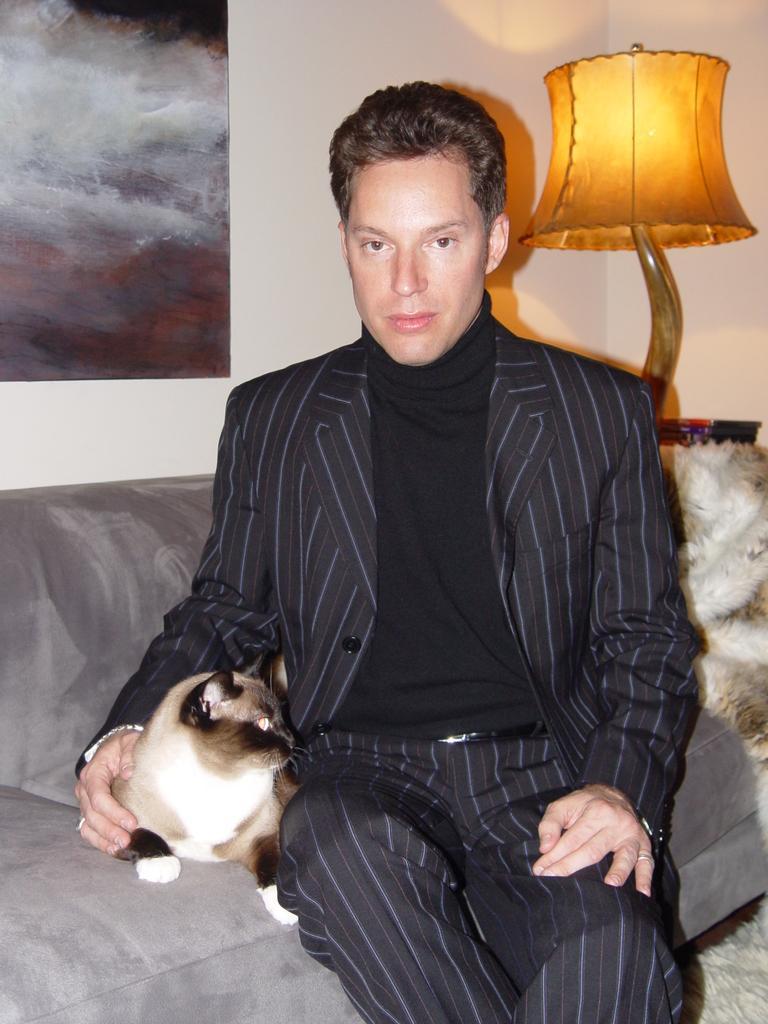Can you describe this image briefly? This is a picture of a person wearing black and white dress sitting on the Sofa on which there is a cat and behind the sofa there is a lamp and a poster to the wall. 